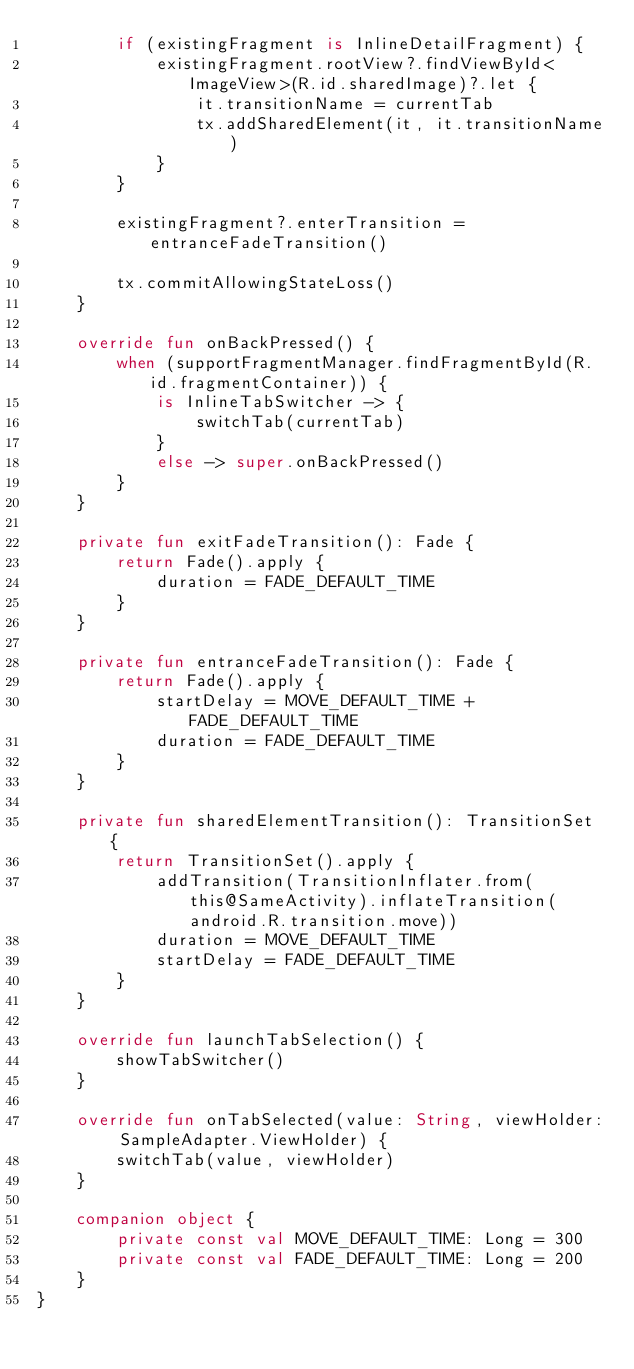<code> <loc_0><loc_0><loc_500><loc_500><_Kotlin_>        if (existingFragment is InlineDetailFragment) {
            existingFragment.rootView?.findViewById<ImageView>(R.id.sharedImage)?.let {
                it.transitionName = currentTab
                tx.addSharedElement(it, it.transitionName)
            }
        }

        existingFragment?.enterTransition = entranceFadeTransition()

        tx.commitAllowingStateLoss()
    }

    override fun onBackPressed() {
        when (supportFragmentManager.findFragmentById(R.id.fragmentContainer)) {
            is InlineTabSwitcher -> {
                switchTab(currentTab)
            }
            else -> super.onBackPressed()
        }
    }

    private fun exitFadeTransition(): Fade {
        return Fade().apply {
            duration = FADE_DEFAULT_TIME
        }
    }

    private fun entranceFadeTransition(): Fade {
        return Fade().apply {
            startDelay = MOVE_DEFAULT_TIME + FADE_DEFAULT_TIME
            duration = FADE_DEFAULT_TIME
        }
    }

    private fun sharedElementTransition(): TransitionSet {
        return TransitionSet().apply {
            addTransition(TransitionInflater.from(this@SameActivity).inflateTransition(android.R.transition.move))
            duration = MOVE_DEFAULT_TIME
            startDelay = FADE_DEFAULT_TIME
        }
    }

    override fun launchTabSelection() {
        showTabSwitcher()
    }

    override fun onTabSelected(value: String, viewHolder: SampleAdapter.ViewHolder) {
        switchTab(value, viewHolder)
    }

    companion object {
        private const val MOVE_DEFAULT_TIME: Long = 300
        private const val FADE_DEFAULT_TIME: Long = 200
    }
}

</code> 